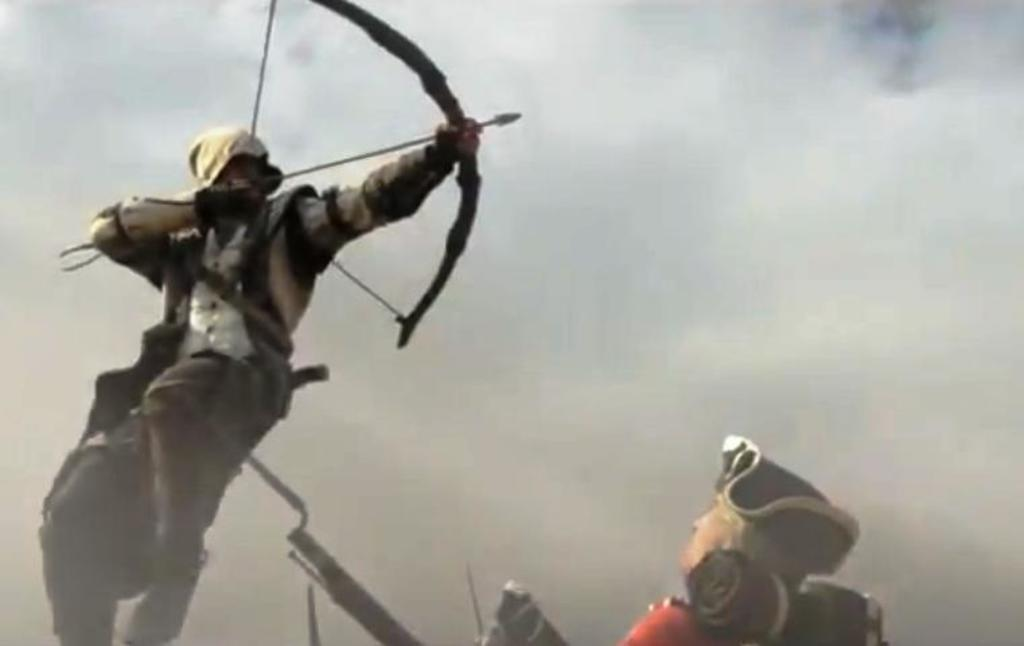What is the person on the left side of the image holding? The person is holding an arrow and a bow in the image. Can you describe the person on the right side of the image? There is another person on the right side of the image, but no specific details about them are provided. What can be seen in the background of the image? The sky is visible in the background of the image. How would you describe the weather based on the sky in the image? The sky appears to be cloudy, which might suggest overcast or potentially rainy weather. What type of dress is the person wearing in the image? There is no mention of a dress in the image, as the person is holding an arrow and a bow. How many eggs are visible in the image? There are no eggs present in the image. 